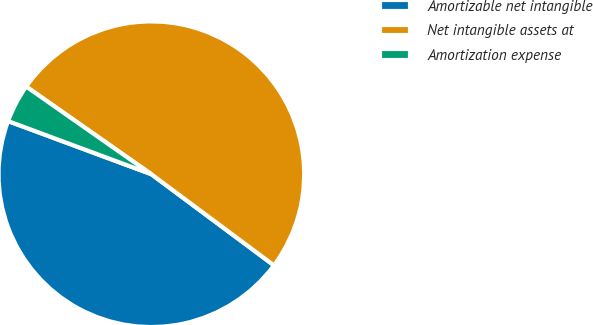<chart> <loc_0><loc_0><loc_500><loc_500><pie_chart><fcel>Amortizable net intangible<fcel>Net intangible assets at<fcel>Amortization expense<nl><fcel>45.48%<fcel>50.45%<fcel>4.07%<nl></chart> 